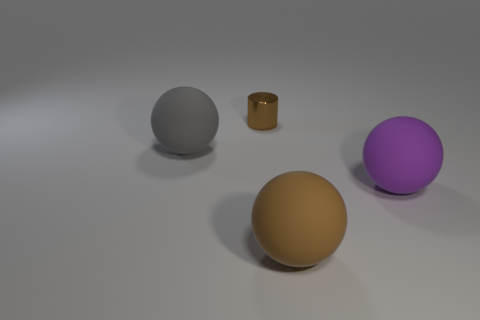Subtract all blue balls. Subtract all blue blocks. How many balls are left? 3 Add 2 metallic cylinders. How many objects exist? 6 Subtract all cylinders. How many objects are left? 3 Add 4 big red rubber things. How many big red rubber things exist? 4 Subtract 0 brown blocks. How many objects are left? 4 Subtract all big brown balls. Subtract all metallic cylinders. How many objects are left? 2 Add 4 purple things. How many purple things are left? 5 